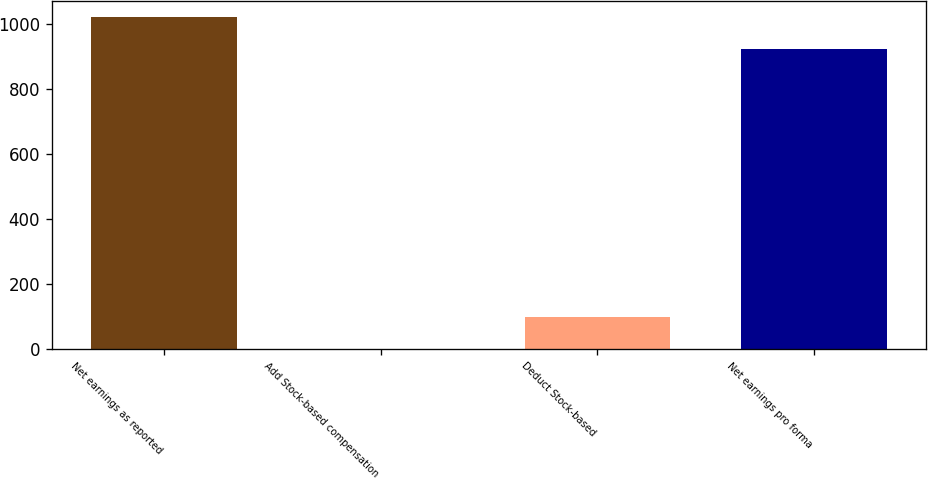Convert chart to OTSL. <chart><loc_0><loc_0><loc_500><loc_500><bar_chart><fcel>Net earnings as reported<fcel>Add Stock-based compensation<fcel>Deduct Stock-based<fcel>Net earnings pro forma<nl><fcel>1021.3<fcel>1<fcel>99.3<fcel>923<nl></chart> 